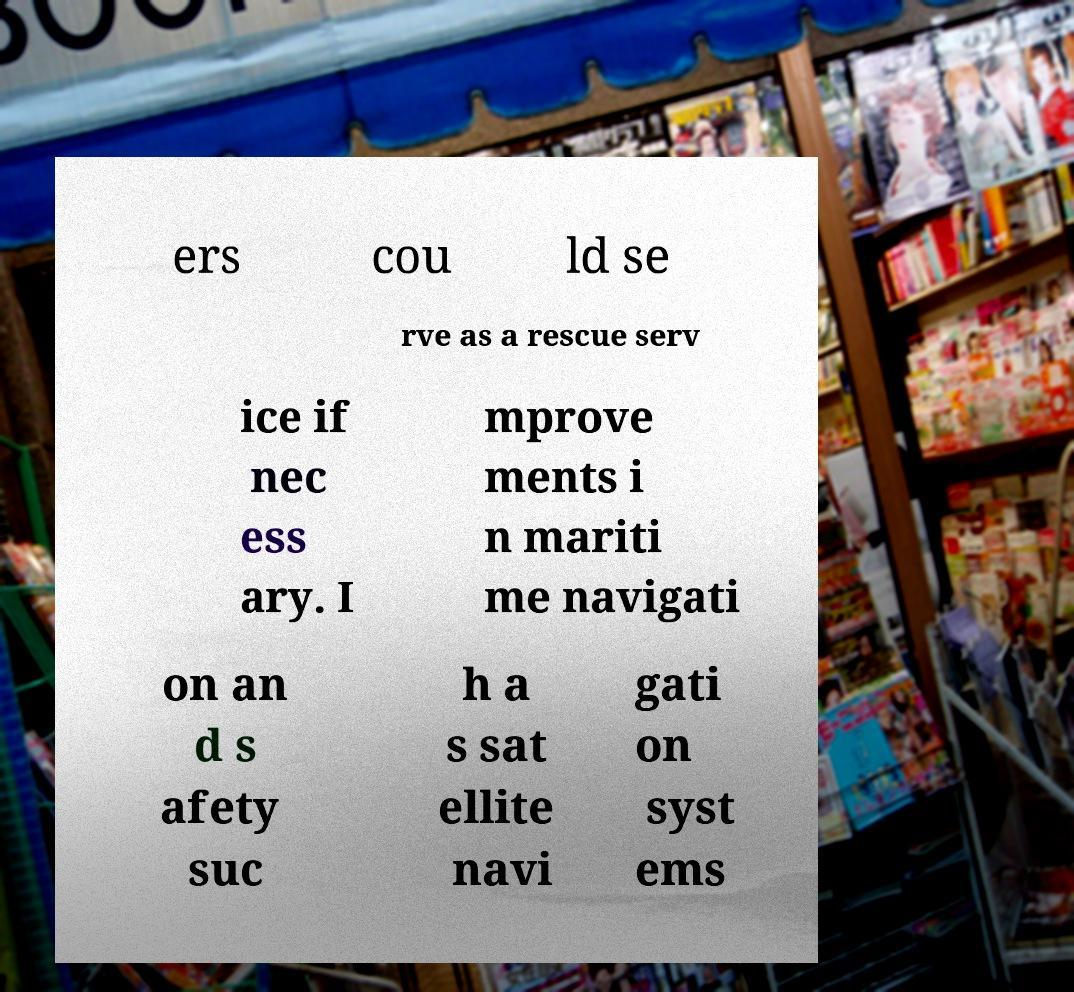Could you assist in decoding the text presented in this image and type it out clearly? ers cou ld se rve as a rescue serv ice if nec ess ary. I mprove ments i n mariti me navigati on an d s afety suc h a s sat ellite navi gati on syst ems 